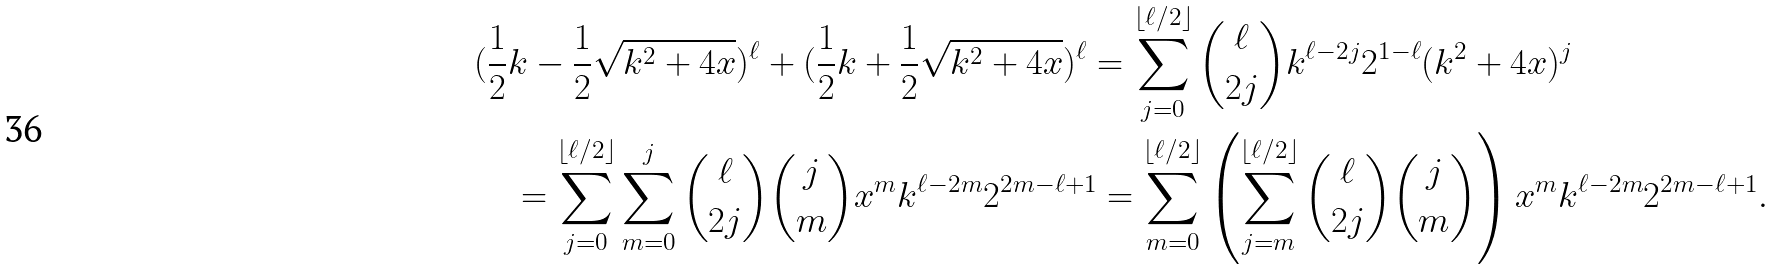<formula> <loc_0><loc_0><loc_500><loc_500>& ( \frac { 1 } { 2 } k - \frac { 1 } { 2 } \sqrt { k ^ { 2 } + 4 x } ) ^ { \ell } + ( \frac { 1 } { 2 } k + \frac { 1 } { 2 } \sqrt { k ^ { 2 } + 4 x } ) ^ { \ell } = \sum _ { j = 0 } ^ { \lfloor \ell / 2 \rfloor } \binom { \ell } { 2 j } k ^ { \ell - 2 j } 2 ^ { 1 - \ell } ( k ^ { 2 } + 4 x ) ^ { j } \\ & \quad = \sum _ { j = 0 } ^ { \lfloor \ell / 2 \rfloor } \sum _ { m = 0 } ^ { j } \binom { \ell } { 2 j } \binom { j } { m } x ^ { m } k ^ { \ell - 2 m } 2 ^ { 2 m - \ell + 1 } = \sum _ { m = 0 } ^ { \lfloor \ell / 2 \rfloor } \left ( \sum _ { j = m } ^ { \lfloor \ell / 2 \rfloor } \binom { \ell } { 2 j } \binom { j } { m } \right ) x ^ { m } k ^ { \ell - 2 m } 2 ^ { 2 m - \ell + 1 } .</formula> 